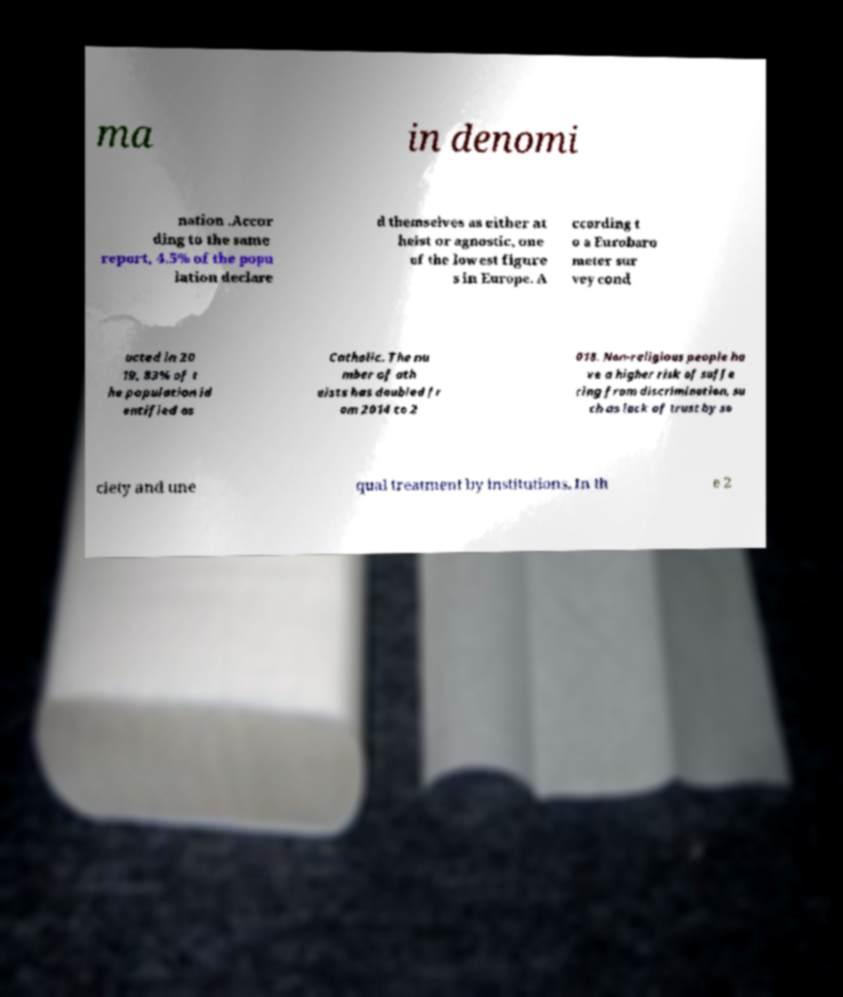I need the written content from this picture converted into text. Can you do that? ma in denomi nation .Accor ding to the same report, 4.5% of the popu lation declare d themselves as either at heist or agnostic, one of the lowest figure s in Europe. A ccording t o a Eurobaro meter sur vey cond ucted in 20 19, 83% of t he population id entified as Catholic. The nu mber of ath eists has doubled fr om 2014 to 2 018. Non-religious people ha ve a higher risk of suffe ring from discrimination, su ch as lack of trust by so ciety and une qual treatment by institutions. In th e 2 